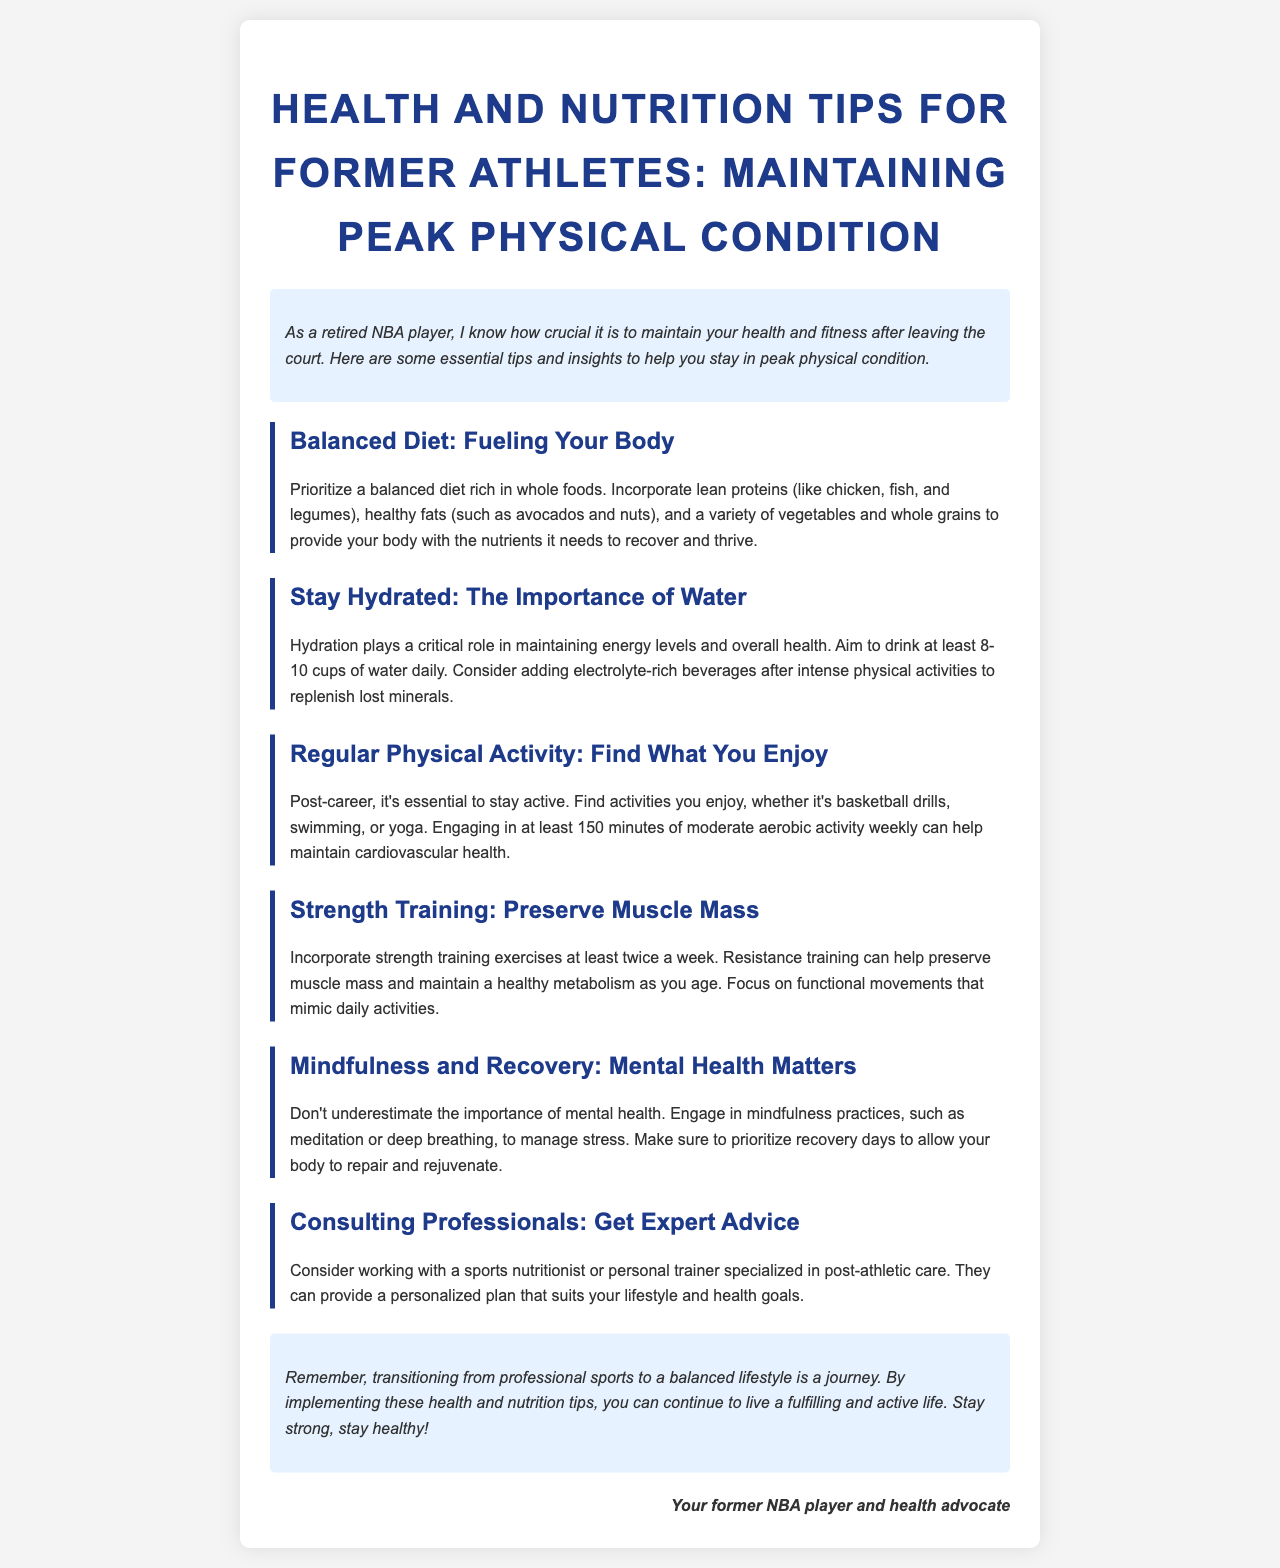what is the title of the newsletter? The title of the newsletter is prominently displayed at the top of the document, which defines the main topic.
Answer: Health and Nutrition Tips for Former Athletes: Maintaining Peak Physical Condition how many cups of water should you aim to drink daily? The document specifies a hydration goal, directly stating the recommended daily amount of water intake.
Answer: 8-10 cups what type of training should be incorporated at least twice a week? The document mentions a specific type of exercise that is essential for preserving physical condition post-career.
Answer: Strength training what is a recommended weekly aerobic activity duration? The newsletter provides a guideline for maintaining cardiovascular health through physical activity, specifying a time frame.
Answer: 150 minutes which types of professional can provide personalized health plans? The document recommends specific experts who can tailor advice for former athletes transitioning to a new lifestyle.
Answer: Sports nutritionist or personal trainer what is emphasized as equally important as physical fitness? The document highlights an aspect of well-being that often gets overlooked but is crucial for overall health.
Answer: Mental health what type of foods should be prioritized in the diet? The text suggests focusing on specific categories of food that are beneficial for maintaining health after athletic careers.
Answer: Whole foods which activity is suggested for mindfulness practices? The document lists a specific practice that contributes to mental well-being and stress management.
Answer: Meditation 